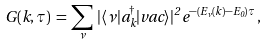Convert formula to latex. <formula><loc_0><loc_0><loc_500><loc_500>G ( { k } , \tau ) \, = \, \sum _ { \nu } \, | \langle \nu | a ^ { \dag } _ { k } | v a c \rangle | ^ { 2 } \, e ^ { - \left ( E _ { \nu } ( { k } ) - E _ { 0 } \right ) \tau } \, ,</formula> 